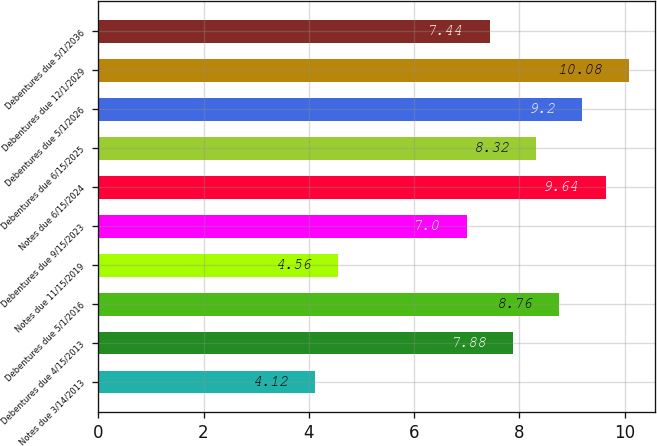<chart> <loc_0><loc_0><loc_500><loc_500><bar_chart><fcel>Notes due 3/14/2013<fcel>Debentures due 4/15/2013<fcel>Debentures due 5/1/2016<fcel>Notes due 11/15/2019<fcel>Debentures due 9/15/2023<fcel>Notes due 6/15/2024<fcel>Debentures due 6/15/2025<fcel>Debentures due 5/1/2026<fcel>Debentures due 12/1/2029<fcel>Debentures due 5/1/2036<nl><fcel>4.12<fcel>7.88<fcel>8.76<fcel>4.56<fcel>7<fcel>9.64<fcel>8.32<fcel>9.2<fcel>10.08<fcel>7.44<nl></chart> 